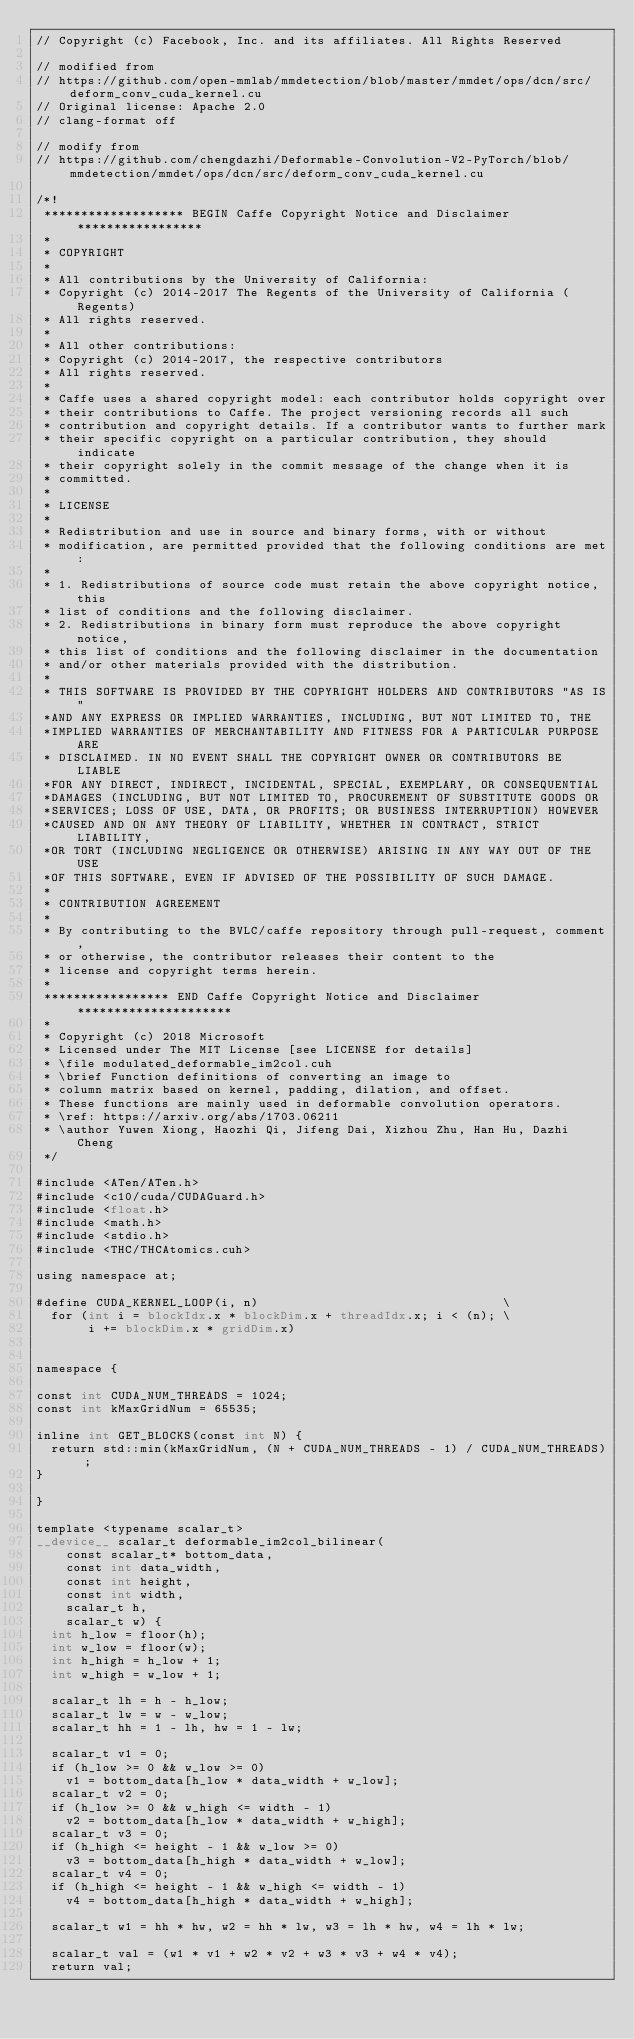<code> <loc_0><loc_0><loc_500><loc_500><_Cuda_>// Copyright (c) Facebook, Inc. and its affiliates. All Rights Reserved

// modified from
// https://github.com/open-mmlab/mmdetection/blob/master/mmdet/ops/dcn/src/deform_conv_cuda_kernel.cu
// Original license: Apache 2.0
// clang-format off

// modify from
// https://github.com/chengdazhi/Deformable-Convolution-V2-PyTorch/blob/mmdetection/mmdet/ops/dcn/src/deform_conv_cuda_kernel.cu

/*!
 ******************* BEGIN Caffe Copyright Notice and Disclaimer *****************
 *
 * COPYRIGHT
 *
 * All contributions by the University of California:
 * Copyright (c) 2014-2017 The Regents of the University of California (Regents)
 * All rights reserved.
 *
 * All other contributions:
 * Copyright (c) 2014-2017, the respective contributors
 * All rights reserved.
 *
 * Caffe uses a shared copyright model: each contributor holds copyright over
 * their contributions to Caffe. The project versioning records all such
 * contribution and copyright details. If a contributor wants to further mark
 * their specific copyright on a particular contribution, they should indicate
 * their copyright solely in the commit message of the change when it is
 * committed.
 *
 * LICENSE
 *
 * Redistribution and use in source and binary forms, with or without
 * modification, are permitted provided that the following conditions are met:
 *
 * 1. Redistributions of source code must retain the above copyright notice, this
 * list of conditions and the following disclaimer.
 * 2. Redistributions in binary form must reproduce the above copyright notice,
 * this list of conditions and the following disclaimer in the documentation
 * and/or other materials provided with the distribution.
 *
 * THIS SOFTWARE IS PROVIDED BY THE COPYRIGHT HOLDERS AND CONTRIBUTORS "AS IS"
 *AND ANY EXPRESS OR IMPLIED WARRANTIES, INCLUDING, BUT NOT LIMITED TO, THE
 *IMPLIED WARRANTIES OF MERCHANTABILITY AND FITNESS FOR A PARTICULAR PURPOSE ARE
 * DISCLAIMED. IN NO EVENT SHALL THE COPYRIGHT OWNER OR CONTRIBUTORS BE LIABLE
 *FOR ANY DIRECT, INDIRECT, INCIDENTAL, SPECIAL, EXEMPLARY, OR CONSEQUENTIAL
 *DAMAGES (INCLUDING, BUT NOT LIMITED TO, PROCUREMENT OF SUBSTITUTE GOODS OR
 *SERVICES; LOSS OF USE, DATA, OR PROFITS; OR BUSINESS INTERRUPTION) HOWEVER
 *CAUSED AND ON ANY THEORY OF LIABILITY, WHETHER IN CONTRACT, STRICT LIABILITY,
 *OR TORT (INCLUDING NEGLIGENCE OR OTHERWISE) ARISING IN ANY WAY OUT OF THE USE
 *OF THIS SOFTWARE, EVEN IF ADVISED OF THE POSSIBILITY OF SUCH DAMAGE.
 *
 * CONTRIBUTION AGREEMENT
 *
 * By contributing to the BVLC/caffe repository through pull-request, comment,
 * or otherwise, the contributor releases their content to the
 * license and copyright terms herein.
 *
 ***************** END Caffe Copyright Notice and Disclaimer *********************
 *
 * Copyright (c) 2018 Microsoft
 * Licensed under The MIT License [see LICENSE for details]
 * \file modulated_deformable_im2col.cuh
 * \brief Function definitions of converting an image to
 * column matrix based on kernel, padding, dilation, and offset.
 * These functions are mainly used in deformable convolution operators.
 * \ref: https://arxiv.org/abs/1703.06211
 * \author Yuwen Xiong, Haozhi Qi, Jifeng Dai, Xizhou Zhu, Han Hu, Dazhi Cheng
 */

#include <ATen/ATen.h>
#include <c10/cuda/CUDAGuard.h>
#include <float.h>
#include <math.h>
#include <stdio.h>
#include <THC/THCAtomics.cuh>

using namespace at;

#define CUDA_KERNEL_LOOP(i, n)                                 \
  for (int i = blockIdx.x * blockDim.x + threadIdx.x; i < (n); \
       i += blockDim.x * gridDim.x)


namespace {

const int CUDA_NUM_THREADS = 1024;
const int kMaxGridNum = 65535;

inline int GET_BLOCKS(const int N) {
  return std::min(kMaxGridNum, (N + CUDA_NUM_THREADS - 1) / CUDA_NUM_THREADS);
}

}

template <typename scalar_t>
__device__ scalar_t deformable_im2col_bilinear(
    const scalar_t* bottom_data,
    const int data_width,
    const int height,
    const int width,
    scalar_t h,
    scalar_t w) {
  int h_low = floor(h);
  int w_low = floor(w);
  int h_high = h_low + 1;
  int w_high = w_low + 1;

  scalar_t lh = h - h_low;
  scalar_t lw = w - w_low;
  scalar_t hh = 1 - lh, hw = 1 - lw;

  scalar_t v1 = 0;
  if (h_low >= 0 && w_low >= 0)
    v1 = bottom_data[h_low * data_width + w_low];
  scalar_t v2 = 0;
  if (h_low >= 0 && w_high <= width - 1)
    v2 = bottom_data[h_low * data_width + w_high];
  scalar_t v3 = 0;
  if (h_high <= height - 1 && w_low >= 0)
    v3 = bottom_data[h_high * data_width + w_low];
  scalar_t v4 = 0;
  if (h_high <= height - 1 && w_high <= width - 1)
    v4 = bottom_data[h_high * data_width + w_high];

  scalar_t w1 = hh * hw, w2 = hh * lw, w3 = lh * hw, w4 = lh * lw;

  scalar_t val = (w1 * v1 + w2 * v2 + w3 * v3 + w4 * v4);
  return val;</code> 